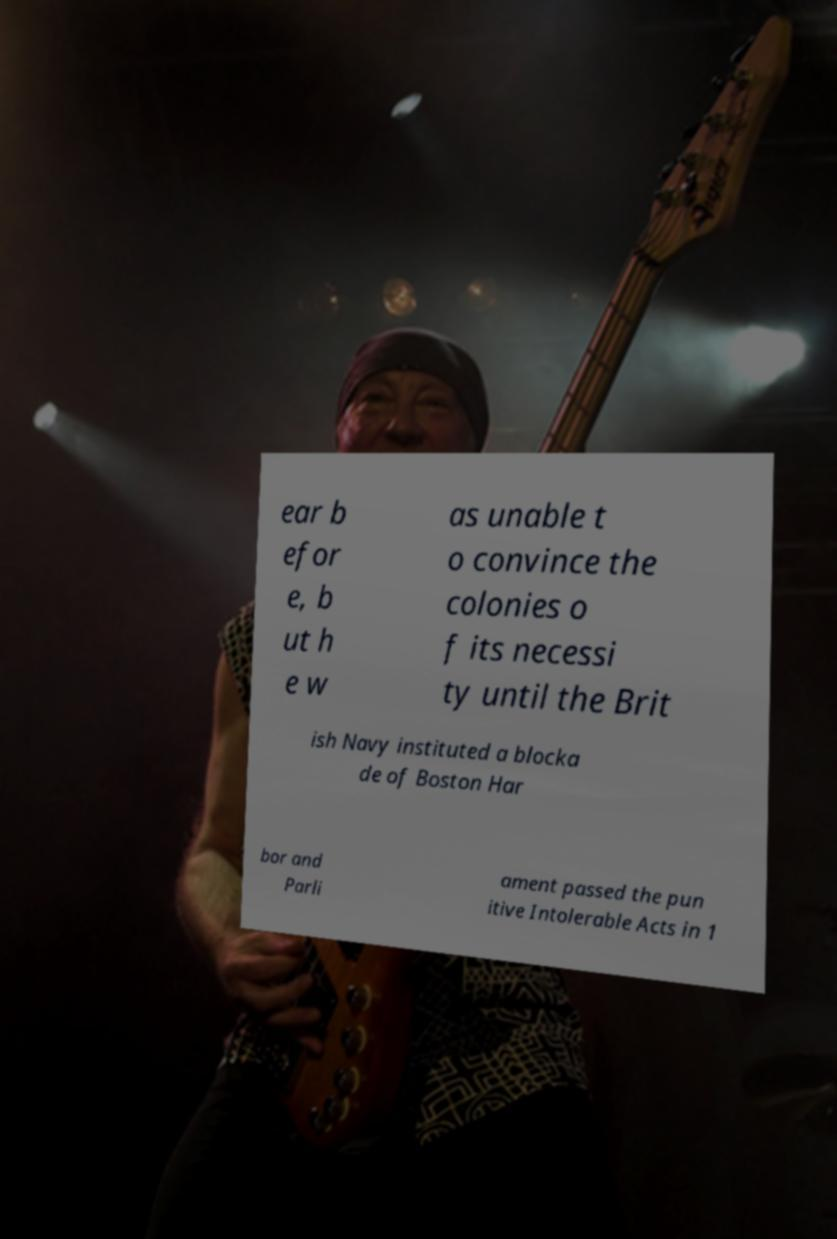Could you assist in decoding the text presented in this image and type it out clearly? ear b efor e, b ut h e w as unable t o convince the colonies o f its necessi ty until the Brit ish Navy instituted a blocka de of Boston Har bor and Parli ament passed the pun itive Intolerable Acts in 1 